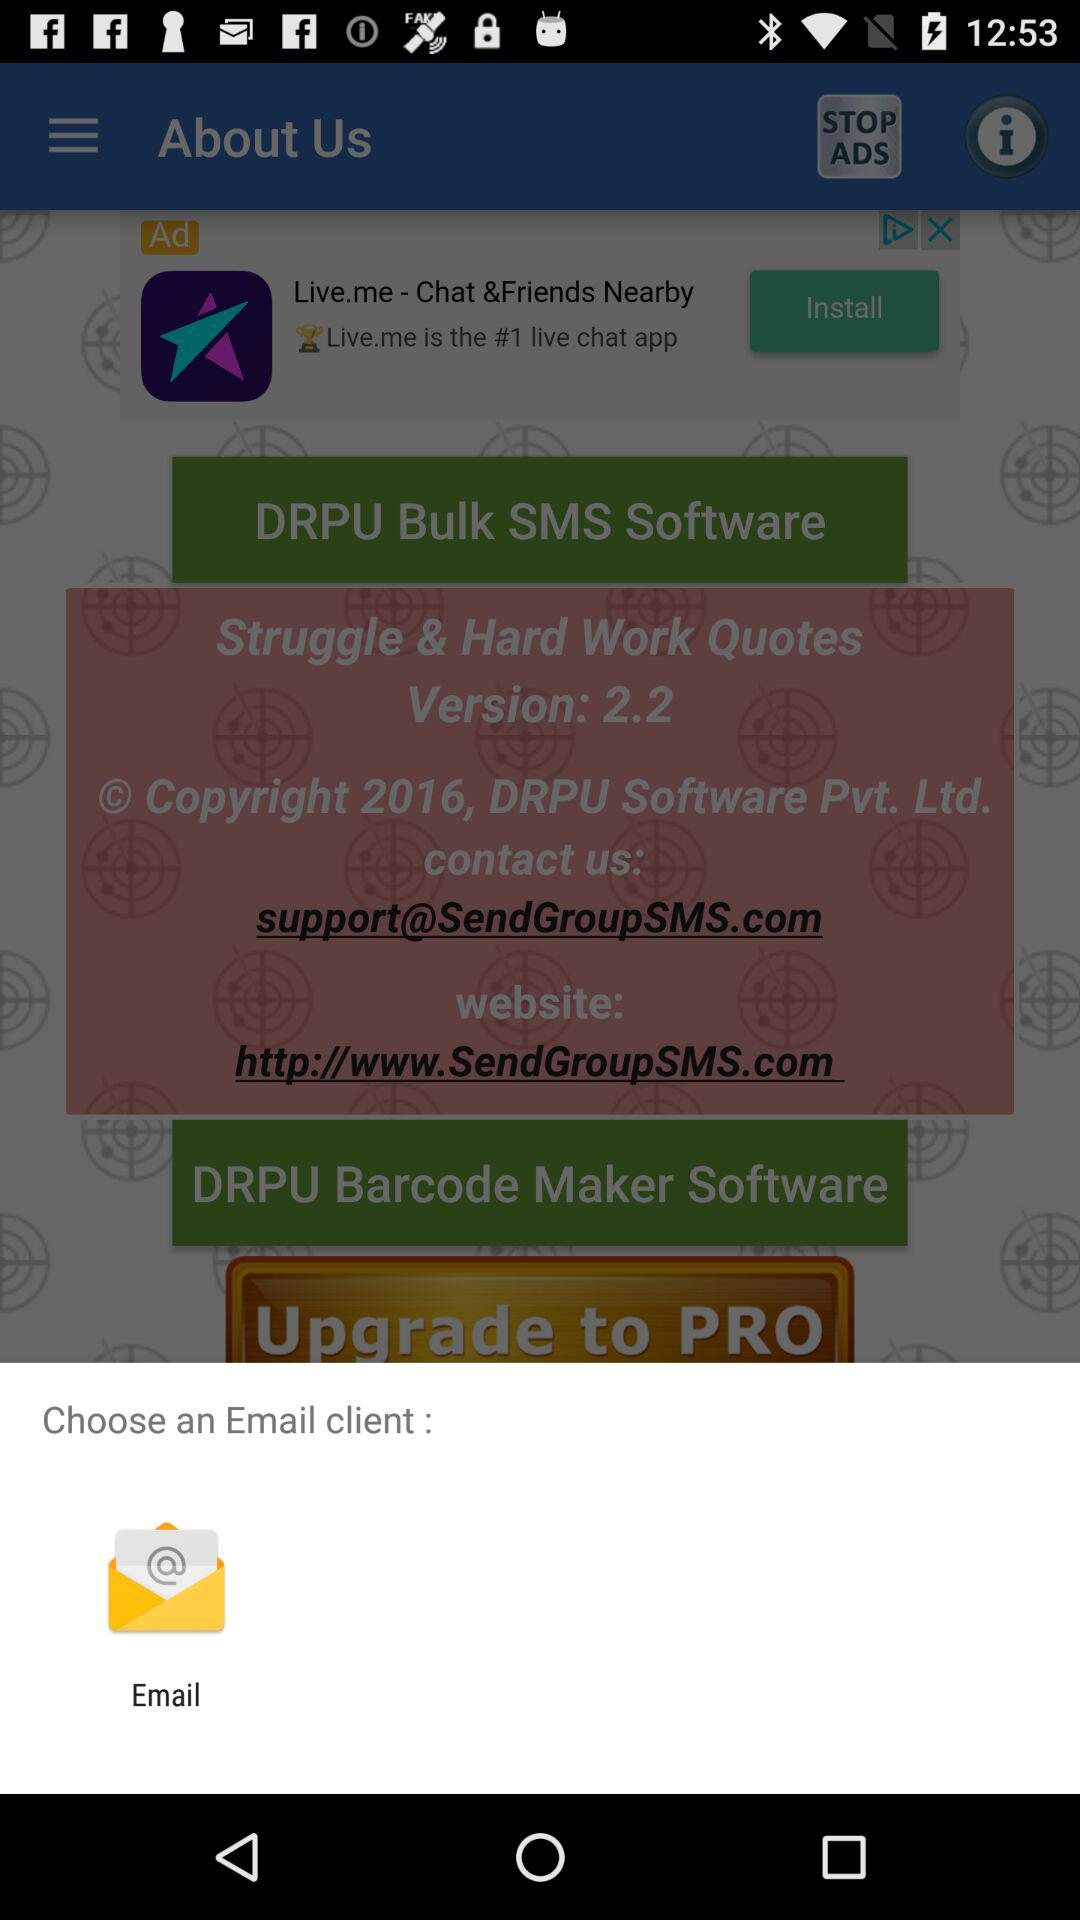What is the version of the software? The version of the software is 2.2. 